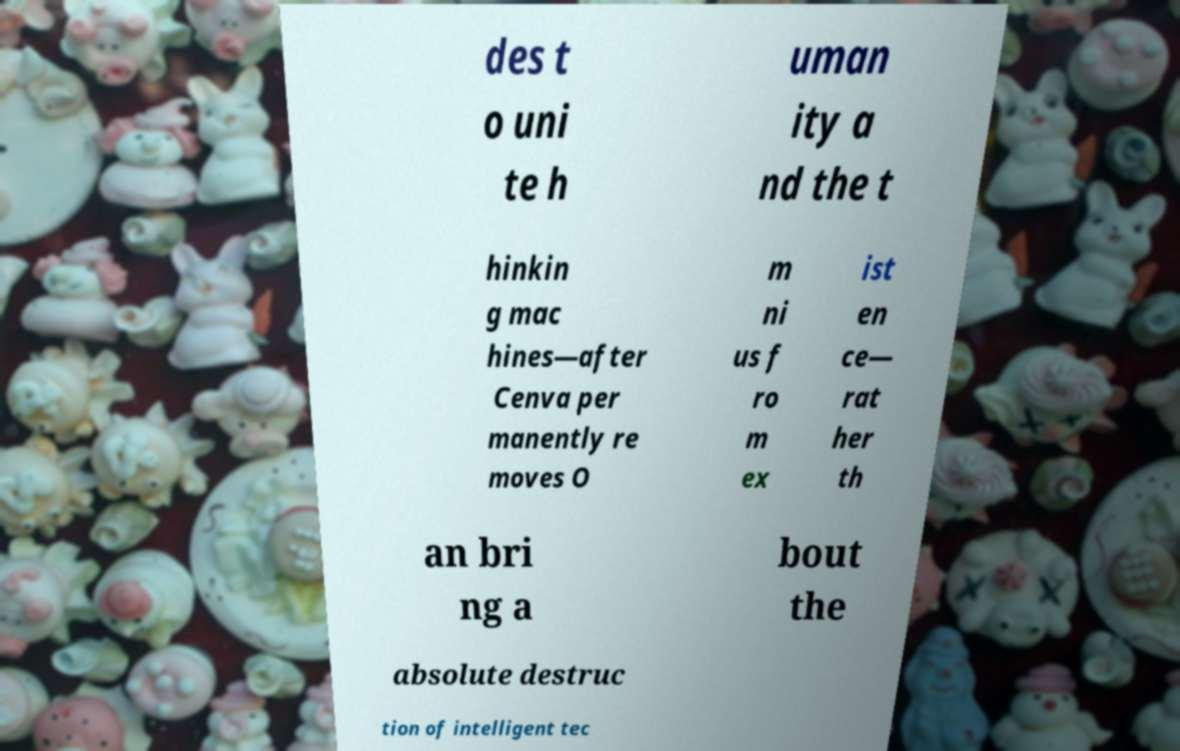Can you read and provide the text displayed in the image?This photo seems to have some interesting text. Can you extract and type it out for me? des t o uni te h uman ity a nd the t hinkin g mac hines—after Cenva per manently re moves O m ni us f ro m ex ist en ce— rat her th an bri ng a bout the absolute destruc tion of intelligent tec 